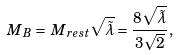<formula> <loc_0><loc_0><loc_500><loc_500>\, M _ { \, B } = \, M _ { r e s t } \sqrt { \tilde { \lambda } } = \frac { 8 \sqrt { \tilde { \lambda } } } { 3 \sqrt { 2 } } ,</formula> 